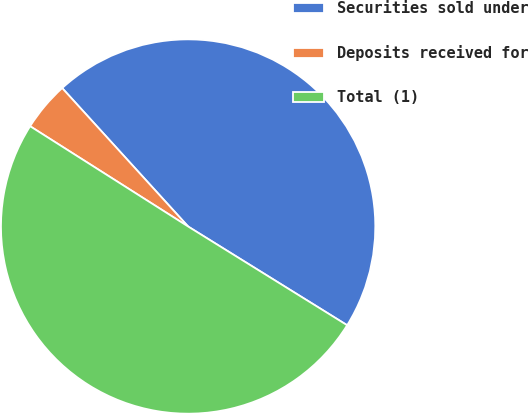<chart> <loc_0><loc_0><loc_500><loc_500><pie_chart><fcel>Securities sold under<fcel>Deposits received for<fcel>Total (1)<nl><fcel>45.59%<fcel>4.25%<fcel>50.16%<nl></chart> 